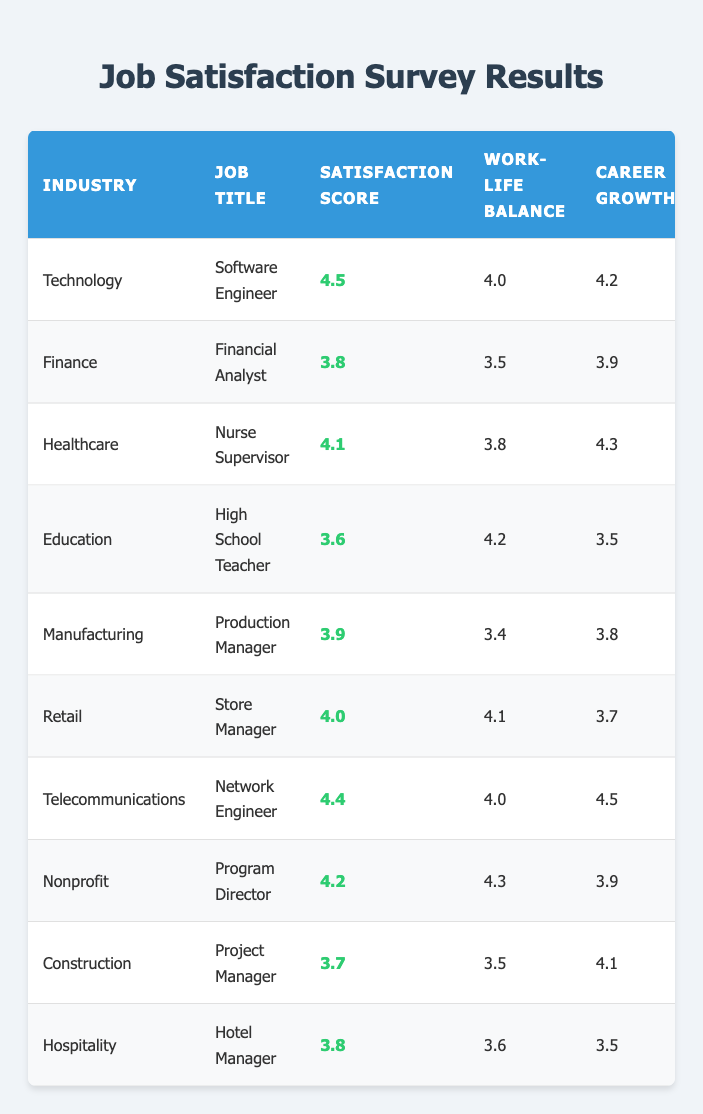What is the satisfaction score for the Software Engineer role in the Technology industry? Referring to the row for the Technology industry and Software Engineer title, the satisfaction score listed is 4.5.
Answer: 4.5 Which industry has the highest satisfaction score? By comparing all the satisfaction scores from the table, Technology has the highest score at 4.5.
Answer: Technology What is the average work-life balance score for jobs in the Education and Nonprofit industries? The work-life balance scores for Education and Nonprofit are 4.2 and 4.3, respectively. Adding them gives 4.2 + 4.3 = 8.5, then dividing by 2 results in an average of 8.5 / 2 = 4.25.
Answer: 4.25 Is the career growth score for Network Engineer higher than that for Financial Analyst? The career growth score for Network Engineer is 4.5, while for Financial Analyst it is 3.9. Since 4.5 is greater than 3.9, the statement is true.
Answer: Yes What is the difference between the highest and lowest salary satisfaction scores in the table? The highest salary satisfaction score is 4.2 from the Hotel Manager role, and the lowest is 3.4 from the Program Director role. The difference is 4.2 - 3.4 = 0.8.
Answer: 0.8 How many industries have a satisfaction score greater than 4.0? The industries with a satisfaction score greater than 4.0 are Technology, Healthcare, Telecommunications, and Nonprofit, which totals to 4 industries.
Answer: 4 What role in the Healthcare industry has the highest career growth score? The only role listed in the Healthcare industry is Nurse Supervisor with a career growth score of 4.3, which is the highest by default.
Answer: Nurse Supervisor Calculate the average satisfaction score for all roles in the table. The satisfaction scores are 4.5, 3.8, 4.1, 3.6, 3.9, 4.0, 4.4, 4.2, 3.7, and 3.8. The total is 4.5 + 3.8 + 4.1 + 3.6 + 3.9 + 4.0 + 4.4 + 4.2 + 3.7 + 3.8 = 40.0 and dividing by 10 gives an average of 40.0 / 10 = 4.0.
Answer: 4.0 Which job title in the Retail industry has the best work-life balance? The job title in the Retail industry is Store Manager, and their work-life balance score is 4.1, which is the only score in that industry.
Answer: Store Manager Is the salary satisfaction score for the Nurse Supervisor higher than the satisfaction score for the High School Teacher? The Nurse Supervisor has a salary satisfaction score of 4.0, while the High School Teacher has a satisfaction score of 3.6. Since 4.0 is greater than 3.6, the claim is true.
Answer: Yes 